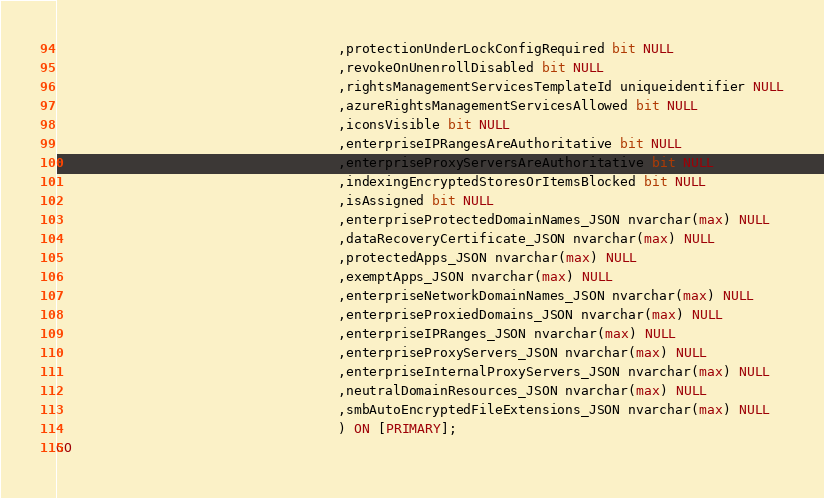Convert code to text. <code><loc_0><loc_0><loc_500><loc_500><_SQL_>                                    ,protectionUnderLockConfigRequired bit NULL
                                    ,revokeOnUnenrollDisabled bit NULL
                                    ,rightsManagementServicesTemplateId uniqueidentifier NULL
                                    ,azureRightsManagementServicesAllowed bit NULL
                                    ,iconsVisible bit NULL
                                    ,enterpriseIPRangesAreAuthoritative bit NULL
                                    ,enterpriseProxyServersAreAuthoritative bit NULL
                                    ,indexingEncryptedStoresOrItemsBlocked bit NULL
                                    ,isAssigned bit NULL
                                    ,enterpriseProtectedDomainNames_JSON nvarchar(max) NULL
                                    ,dataRecoveryCertificate_JSON nvarchar(max) NULL
                                    ,protectedApps_JSON nvarchar(max) NULL
                                    ,exemptApps_JSON nvarchar(max) NULL
                                    ,enterpriseNetworkDomainNames_JSON nvarchar(max) NULL
                                    ,enterpriseProxiedDomains_JSON nvarchar(max) NULL
                                    ,enterpriseIPRanges_JSON nvarchar(max) NULL
                                    ,enterpriseProxyServers_JSON nvarchar(max) NULL
                                    ,enterpriseInternalProxyServers_JSON nvarchar(max) NULL
                                    ,neutralDomainResources_JSON nvarchar(max) NULL
                                    ,smbAutoEncryptedFileExtensions_JSON nvarchar(max) NULL
                                    ) ON [PRIMARY];
GO
</code> 